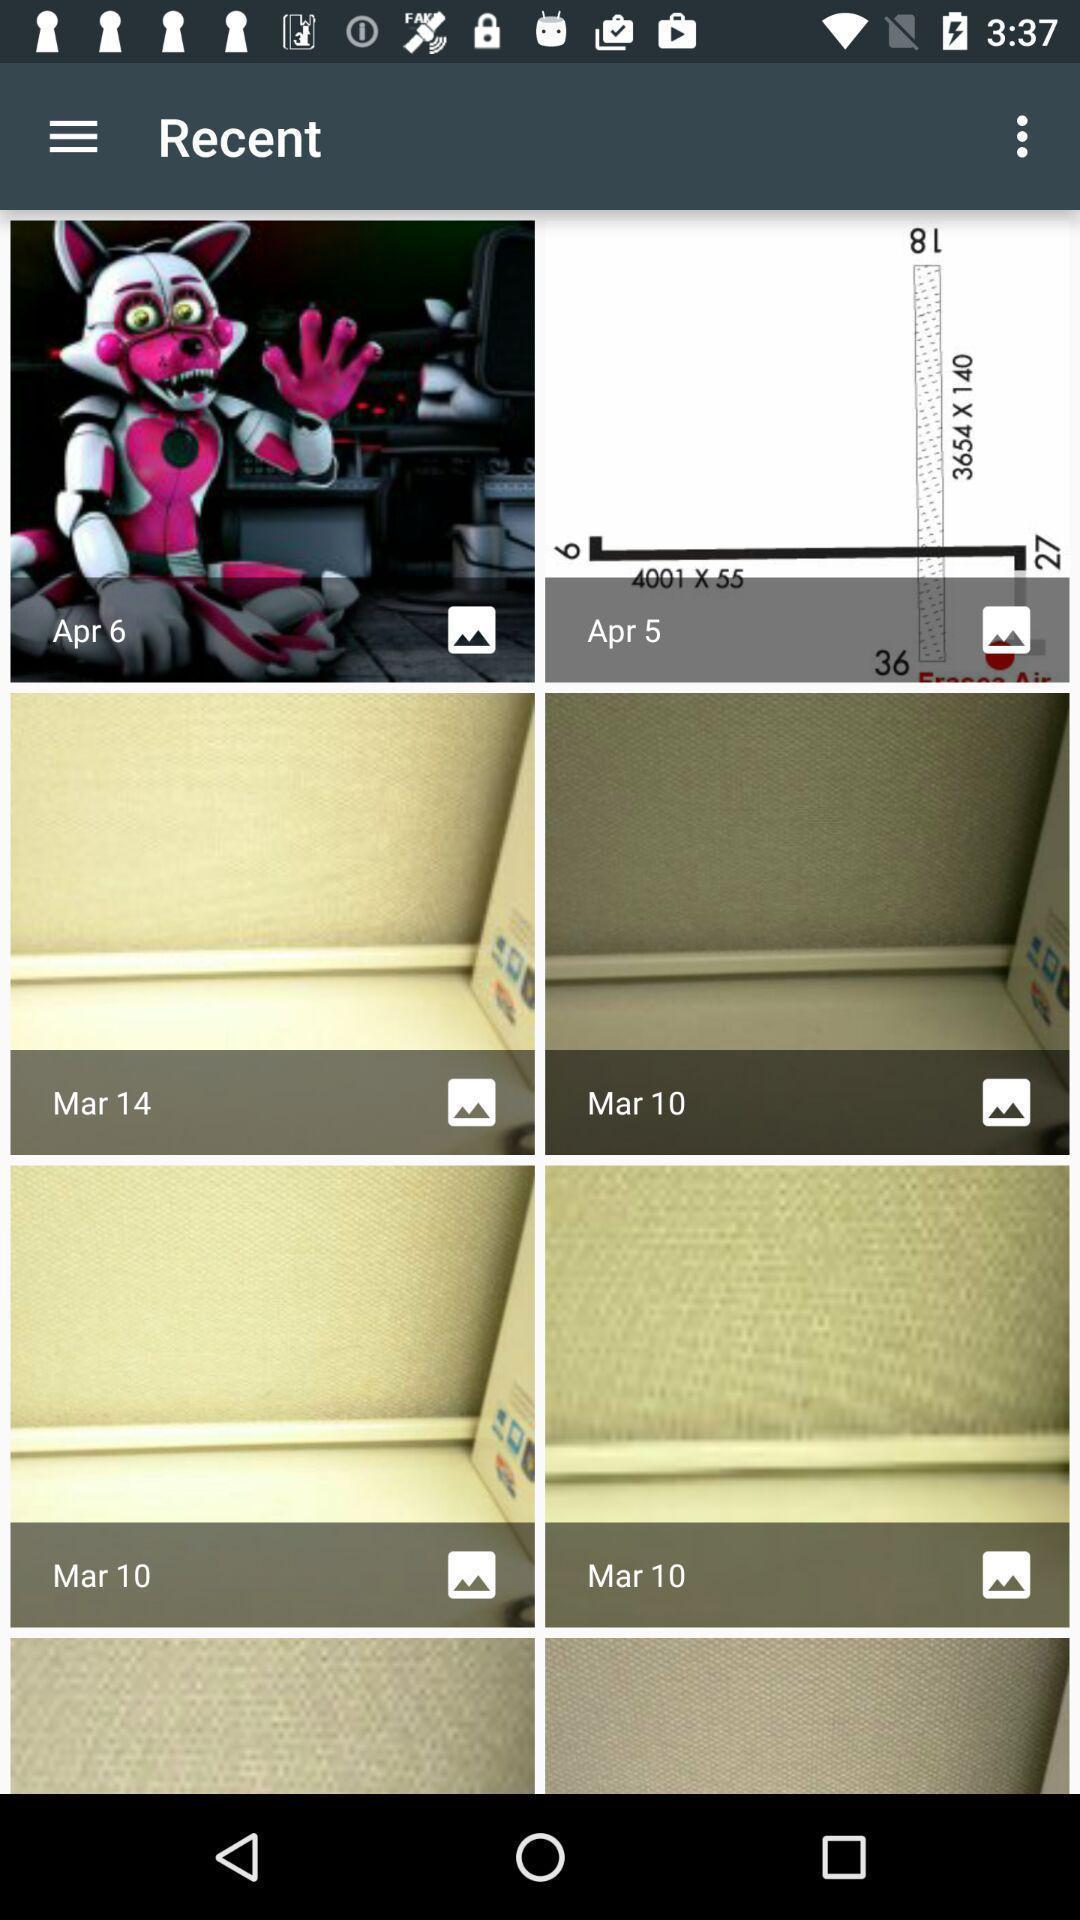Please provide a description for this image. Various recent images page displayed. 